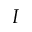<formula> <loc_0><loc_0><loc_500><loc_500>I</formula> 